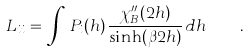Convert formula to latex. <formula><loc_0><loc_0><loc_500><loc_500>L _ { i i } = \, \int \, P _ { i } ( h ) \, \frac { \chi _ { B } ^ { \prime \prime } ( 2 h ) } { \sinh ( \beta 2 h ) } \, d h \quad .</formula> 